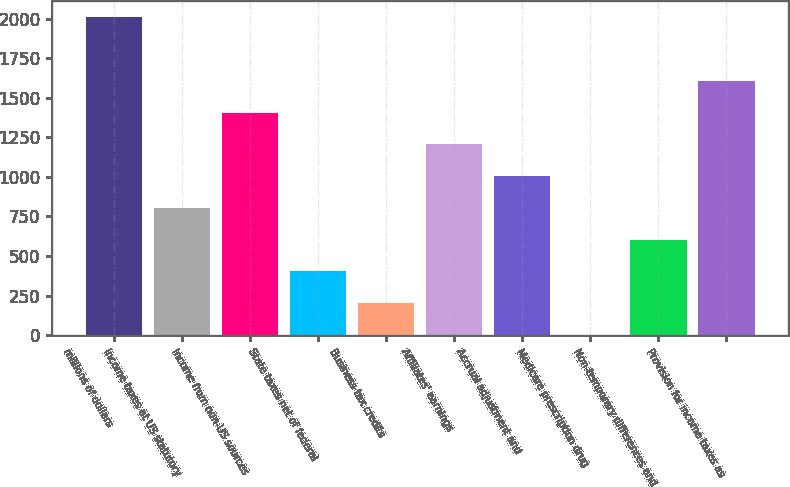<chart> <loc_0><loc_0><loc_500><loc_500><bar_chart><fcel>millions of dollars<fcel>Income taxes at US statutory<fcel>Income from non-US sources<fcel>State taxes net of federal<fcel>Business tax credits<fcel>Affiliates' earnings<fcel>Accrual adjustment and<fcel>Medicare prescription drug<fcel>Non-temporary differences and<fcel>Provision for income taxes as<nl><fcel>2009<fcel>804.62<fcel>1406.81<fcel>403.16<fcel>202.43<fcel>1206.08<fcel>1005.35<fcel>1.7<fcel>603.89<fcel>1607.54<nl></chart> 